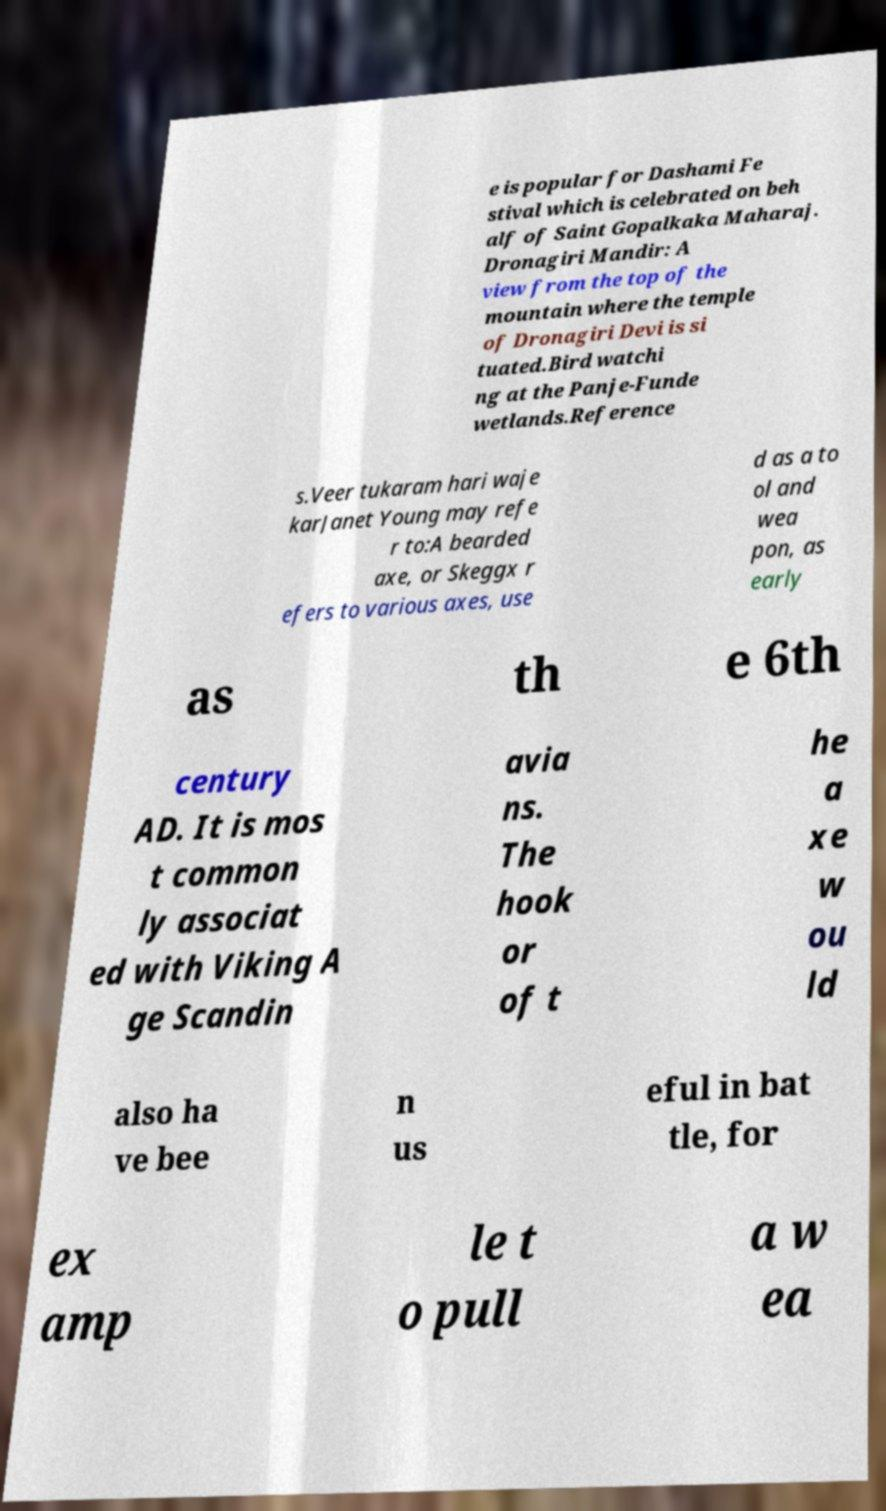Can you accurately transcribe the text from the provided image for me? e is popular for Dashami Fe stival which is celebrated on beh alf of Saint Gopalkaka Maharaj. Dronagiri Mandir: A view from the top of the mountain where the temple of Dronagiri Devi is si tuated.Bird watchi ng at the Panje-Funde wetlands.Reference s.Veer tukaram hari waje karJanet Young may refe r to:A bearded axe, or Skeggx r efers to various axes, use d as a to ol and wea pon, as early as th e 6th century AD. It is mos t common ly associat ed with Viking A ge Scandin avia ns. The hook or of t he a xe w ou ld also ha ve bee n us eful in bat tle, for ex amp le t o pull a w ea 